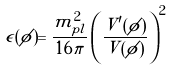Convert formula to latex. <formula><loc_0><loc_0><loc_500><loc_500>\epsilon ( \phi ) = \frac { m _ { p l } ^ { 2 } } { 1 6 \pi } \left ( \frac { V ^ { \prime } ( \phi ) } { V ( \phi ) } \right ) ^ { 2 }</formula> 